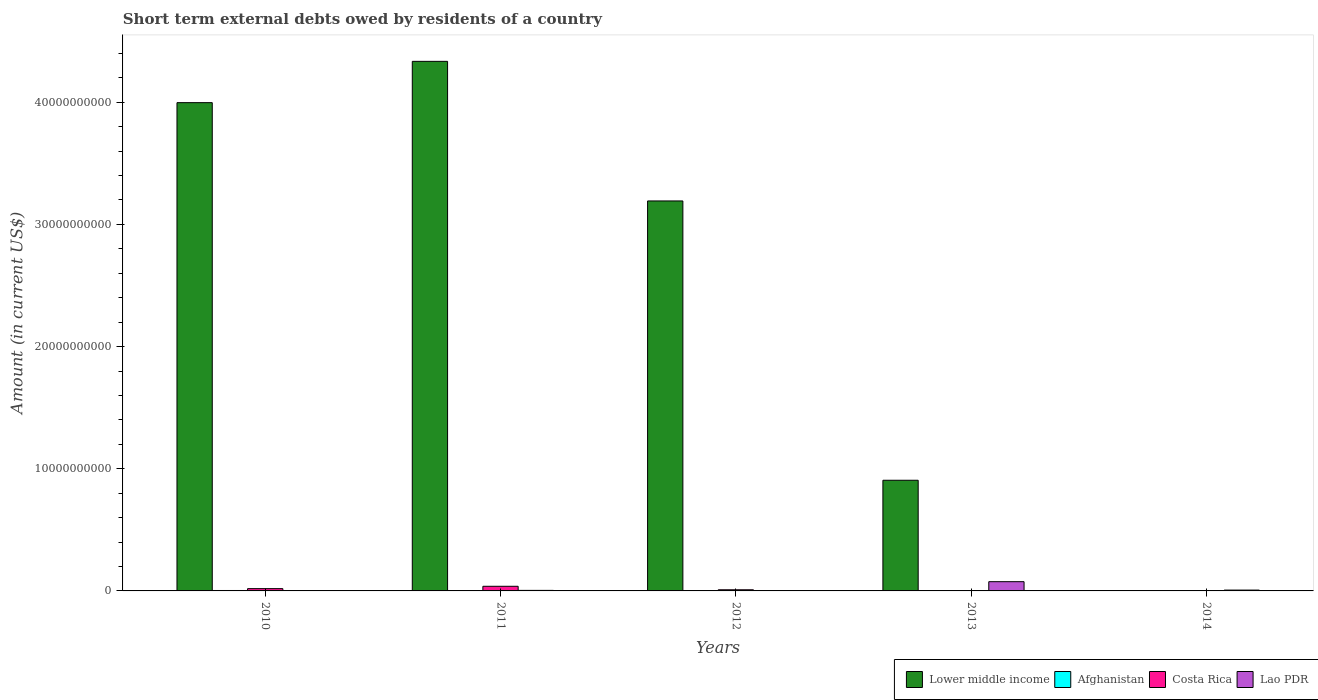How many groups of bars are there?
Provide a short and direct response. 5. What is the label of the 2nd group of bars from the left?
Ensure brevity in your answer.  2011. What is the amount of short-term external debts owed by residents in Lower middle income in 2013?
Ensure brevity in your answer.  9.06e+09. Across all years, what is the maximum amount of short-term external debts owed by residents in Afghanistan?
Your response must be concise. 3.50e+07. Across all years, what is the minimum amount of short-term external debts owed by residents in Lao PDR?
Ensure brevity in your answer.  0. What is the total amount of short-term external debts owed by residents in Costa Rica in the graph?
Your response must be concise. 6.60e+08. What is the difference between the amount of short-term external debts owed by residents in Costa Rica in 2011 and that in 2012?
Keep it short and to the point. 2.86e+08. What is the difference between the amount of short-term external debts owed by residents in Lower middle income in 2011 and the amount of short-term external debts owed by residents in Lao PDR in 2014?
Offer a very short reply. 4.33e+1. What is the average amount of short-term external debts owed by residents in Afghanistan per year?
Ensure brevity in your answer.  1.16e+07. In the year 2011, what is the difference between the amount of short-term external debts owed by residents in Costa Rica and amount of short-term external debts owed by residents in Lower middle income?
Keep it short and to the point. -4.30e+1. In how many years, is the amount of short-term external debts owed by residents in Lao PDR greater than 28000000000 US$?
Give a very brief answer. 0. What is the ratio of the amount of short-term external debts owed by residents in Afghanistan in 2012 to that in 2014?
Provide a short and direct response. 0.64. Is the difference between the amount of short-term external debts owed by residents in Costa Rica in 2011 and 2012 greater than the difference between the amount of short-term external debts owed by residents in Lower middle income in 2011 and 2012?
Your answer should be very brief. No. What is the difference between the highest and the second highest amount of short-term external debts owed by residents in Costa Rica?
Offer a very short reply. 1.92e+08. What is the difference between the highest and the lowest amount of short-term external debts owed by residents in Afghanistan?
Offer a terse response. 3.50e+07. In how many years, is the amount of short-term external debts owed by residents in Lao PDR greater than the average amount of short-term external debts owed by residents in Lao PDR taken over all years?
Offer a terse response. 1. Is the sum of the amount of short-term external debts owed by residents in Lower middle income in 2012 and 2013 greater than the maximum amount of short-term external debts owed by residents in Costa Rica across all years?
Give a very brief answer. Yes. Is it the case that in every year, the sum of the amount of short-term external debts owed by residents in Afghanistan and amount of short-term external debts owed by residents in Lao PDR is greater than the sum of amount of short-term external debts owed by residents in Lower middle income and amount of short-term external debts owed by residents in Costa Rica?
Ensure brevity in your answer.  No. How many bars are there?
Give a very brief answer. 13. Are the values on the major ticks of Y-axis written in scientific E-notation?
Ensure brevity in your answer.  No. Does the graph contain any zero values?
Offer a very short reply. Yes. Does the graph contain grids?
Keep it short and to the point. No. How many legend labels are there?
Make the answer very short. 4. How are the legend labels stacked?
Keep it short and to the point. Horizontal. What is the title of the graph?
Provide a succinct answer. Short term external debts owed by residents of a country. Does "Paraguay" appear as one of the legend labels in the graph?
Provide a short and direct response. No. What is the label or title of the Y-axis?
Keep it short and to the point. Amount (in current US$). What is the Amount (in current US$) in Lower middle income in 2010?
Make the answer very short. 4.00e+1. What is the Amount (in current US$) in Afghanistan in 2010?
Provide a short and direct response. 3.50e+07. What is the Amount (in current US$) of Costa Rica in 2010?
Ensure brevity in your answer.  1.88e+08. What is the Amount (in current US$) of Lao PDR in 2010?
Your response must be concise. 0. What is the Amount (in current US$) in Lower middle income in 2011?
Provide a short and direct response. 4.33e+1. What is the Amount (in current US$) in Costa Rica in 2011?
Keep it short and to the point. 3.79e+08. What is the Amount (in current US$) in Lao PDR in 2011?
Give a very brief answer. 4.40e+07. What is the Amount (in current US$) of Lower middle income in 2012?
Keep it short and to the point. 3.19e+1. What is the Amount (in current US$) of Afghanistan in 2012?
Your response must be concise. 9.00e+06. What is the Amount (in current US$) of Costa Rica in 2012?
Keep it short and to the point. 9.34e+07. What is the Amount (in current US$) in Lower middle income in 2013?
Your answer should be compact. 9.06e+09. What is the Amount (in current US$) of Costa Rica in 2013?
Ensure brevity in your answer.  0. What is the Amount (in current US$) of Lao PDR in 2013?
Your answer should be very brief. 7.56e+08. What is the Amount (in current US$) in Lower middle income in 2014?
Your answer should be very brief. 0. What is the Amount (in current US$) of Afghanistan in 2014?
Offer a very short reply. 1.40e+07. What is the Amount (in current US$) of Lao PDR in 2014?
Keep it short and to the point. 6.80e+07. Across all years, what is the maximum Amount (in current US$) in Lower middle income?
Give a very brief answer. 4.33e+1. Across all years, what is the maximum Amount (in current US$) of Afghanistan?
Keep it short and to the point. 3.50e+07. Across all years, what is the maximum Amount (in current US$) in Costa Rica?
Offer a very short reply. 3.79e+08. Across all years, what is the maximum Amount (in current US$) in Lao PDR?
Keep it short and to the point. 7.56e+08. Across all years, what is the minimum Amount (in current US$) of Lower middle income?
Provide a succinct answer. 0. Across all years, what is the minimum Amount (in current US$) in Afghanistan?
Provide a succinct answer. 0. What is the total Amount (in current US$) in Lower middle income in the graph?
Provide a succinct answer. 1.24e+11. What is the total Amount (in current US$) in Afghanistan in the graph?
Your answer should be very brief. 5.80e+07. What is the total Amount (in current US$) of Costa Rica in the graph?
Make the answer very short. 6.60e+08. What is the total Amount (in current US$) of Lao PDR in the graph?
Offer a very short reply. 8.68e+08. What is the difference between the Amount (in current US$) in Lower middle income in 2010 and that in 2011?
Your answer should be very brief. -3.38e+09. What is the difference between the Amount (in current US$) of Costa Rica in 2010 and that in 2011?
Offer a very short reply. -1.92e+08. What is the difference between the Amount (in current US$) in Lower middle income in 2010 and that in 2012?
Offer a terse response. 8.05e+09. What is the difference between the Amount (in current US$) of Afghanistan in 2010 and that in 2012?
Your answer should be very brief. 2.60e+07. What is the difference between the Amount (in current US$) of Costa Rica in 2010 and that in 2012?
Offer a very short reply. 9.42e+07. What is the difference between the Amount (in current US$) in Lower middle income in 2010 and that in 2013?
Keep it short and to the point. 3.09e+1. What is the difference between the Amount (in current US$) in Afghanistan in 2010 and that in 2014?
Your response must be concise. 2.10e+07. What is the difference between the Amount (in current US$) in Lower middle income in 2011 and that in 2012?
Your answer should be very brief. 1.14e+1. What is the difference between the Amount (in current US$) of Costa Rica in 2011 and that in 2012?
Give a very brief answer. 2.86e+08. What is the difference between the Amount (in current US$) of Lower middle income in 2011 and that in 2013?
Offer a very short reply. 3.43e+1. What is the difference between the Amount (in current US$) in Lao PDR in 2011 and that in 2013?
Offer a terse response. -7.12e+08. What is the difference between the Amount (in current US$) in Lao PDR in 2011 and that in 2014?
Give a very brief answer. -2.40e+07. What is the difference between the Amount (in current US$) in Lower middle income in 2012 and that in 2013?
Your answer should be compact. 2.29e+1. What is the difference between the Amount (in current US$) in Afghanistan in 2012 and that in 2014?
Provide a succinct answer. -5.00e+06. What is the difference between the Amount (in current US$) of Lao PDR in 2013 and that in 2014?
Your response must be concise. 6.88e+08. What is the difference between the Amount (in current US$) in Lower middle income in 2010 and the Amount (in current US$) in Costa Rica in 2011?
Make the answer very short. 3.96e+1. What is the difference between the Amount (in current US$) of Lower middle income in 2010 and the Amount (in current US$) of Lao PDR in 2011?
Keep it short and to the point. 3.99e+1. What is the difference between the Amount (in current US$) of Afghanistan in 2010 and the Amount (in current US$) of Costa Rica in 2011?
Provide a short and direct response. -3.44e+08. What is the difference between the Amount (in current US$) in Afghanistan in 2010 and the Amount (in current US$) in Lao PDR in 2011?
Provide a succinct answer. -9.00e+06. What is the difference between the Amount (in current US$) of Costa Rica in 2010 and the Amount (in current US$) of Lao PDR in 2011?
Ensure brevity in your answer.  1.44e+08. What is the difference between the Amount (in current US$) in Lower middle income in 2010 and the Amount (in current US$) in Afghanistan in 2012?
Ensure brevity in your answer.  4.00e+1. What is the difference between the Amount (in current US$) of Lower middle income in 2010 and the Amount (in current US$) of Costa Rica in 2012?
Offer a very short reply. 3.99e+1. What is the difference between the Amount (in current US$) in Afghanistan in 2010 and the Amount (in current US$) in Costa Rica in 2012?
Provide a succinct answer. -5.84e+07. What is the difference between the Amount (in current US$) in Lower middle income in 2010 and the Amount (in current US$) in Lao PDR in 2013?
Provide a succinct answer. 3.92e+1. What is the difference between the Amount (in current US$) of Afghanistan in 2010 and the Amount (in current US$) of Lao PDR in 2013?
Your answer should be compact. -7.21e+08. What is the difference between the Amount (in current US$) of Costa Rica in 2010 and the Amount (in current US$) of Lao PDR in 2013?
Your response must be concise. -5.68e+08. What is the difference between the Amount (in current US$) in Lower middle income in 2010 and the Amount (in current US$) in Afghanistan in 2014?
Make the answer very short. 4.00e+1. What is the difference between the Amount (in current US$) in Lower middle income in 2010 and the Amount (in current US$) in Lao PDR in 2014?
Offer a very short reply. 3.99e+1. What is the difference between the Amount (in current US$) in Afghanistan in 2010 and the Amount (in current US$) in Lao PDR in 2014?
Offer a very short reply. -3.30e+07. What is the difference between the Amount (in current US$) in Costa Rica in 2010 and the Amount (in current US$) in Lao PDR in 2014?
Your answer should be very brief. 1.20e+08. What is the difference between the Amount (in current US$) of Lower middle income in 2011 and the Amount (in current US$) of Afghanistan in 2012?
Give a very brief answer. 4.33e+1. What is the difference between the Amount (in current US$) of Lower middle income in 2011 and the Amount (in current US$) of Costa Rica in 2012?
Your answer should be very brief. 4.33e+1. What is the difference between the Amount (in current US$) in Lower middle income in 2011 and the Amount (in current US$) in Lao PDR in 2013?
Offer a very short reply. 4.26e+1. What is the difference between the Amount (in current US$) in Costa Rica in 2011 and the Amount (in current US$) in Lao PDR in 2013?
Your answer should be very brief. -3.77e+08. What is the difference between the Amount (in current US$) in Lower middle income in 2011 and the Amount (in current US$) in Afghanistan in 2014?
Keep it short and to the point. 4.33e+1. What is the difference between the Amount (in current US$) of Lower middle income in 2011 and the Amount (in current US$) of Lao PDR in 2014?
Keep it short and to the point. 4.33e+1. What is the difference between the Amount (in current US$) in Costa Rica in 2011 and the Amount (in current US$) in Lao PDR in 2014?
Provide a short and direct response. 3.11e+08. What is the difference between the Amount (in current US$) of Lower middle income in 2012 and the Amount (in current US$) of Lao PDR in 2013?
Provide a succinct answer. 3.12e+1. What is the difference between the Amount (in current US$) in Afghanistan in 2012 and the Amount (in current US$) in Lao PDR in 2013?
Offer a terse response. -7.47e+08. What is the difference between the Amount (in current US$) of Costa Rica in 2012 and the Amount (in current US$) of Lao PDR in 2013?
Your answer should be very brief. -6.63e+08. What is the difference between the Amount (in current US$) in Lower middle income in 2012 and the Amount (in current US$) in Afghanistan in 2014?
Your answer should be compact. 3.19e+1. What is the difference between the Amount (in current US$) in Lower middle income in 2012 and the Amount (in current US$) in Lao PDR in 2014?
Give a very brief answer. 3.19e+1. What is the difference between the Amount (in current US$) in Afghanistan in 2012 and the Amount (in current US$) in Lao PDR in 2014?
Your answer should be compact. -5.90e+07. What is the difference between the Amount (in current US$) in Costa Rica in 2012 and the Amount (in current US$) in Lao PDR in 2014?
Provide a succinct answer. 2.54e+07. What is the difference between the Amount (in current US$) in Lower middle income in 2013 and the Amount (in current US$) in Afghanistan in 2014?
Provide a succinct answer. 9.04e+09. What is the difference between the Amount (in current US$) of Lower middle income in 2013 and the Amount (in current US$) of Lao PDR in 2014?
Provide a short and direct response. 8.99e+09. What is the average Amount (in current US$) of Lower middle income per year?
Offer a very short reply. 2.49e+1. What is the average Amount (in current US$) in Afghanistan per year?
Keep it short and to the point. 1.16e+07. What is the average Amount (in current US$) in Costa Rica per year?
Your answer should be compact. 1.32e+08. What is the average Amount (in current US$) in Lao PDR per year?
Give a very brief answer. 1.74e+08. In the year 2010, what is the difference between the Amount (in current US$) of Lower middle income and Amount (in current US$) of Afghanistan?
Provide a short and direct response. 3.99e+1. In the year 2010, what is the difference between the Amount (in current US$) in Lower middle income and Amount (in current US$) in Costa Rica?
Your answer should be very brief. 3.98e+1. In the year 2010, what is the difference between the Amount (in current US$) in Afghanistan and Amount (in current US$) in Costa Rica?
Provide a succinct answer. -1.53e+08. In the year 2011, what is the difference between the Amount (in current US$) in Lower middle income and Amount (in current US$) in Costa Rica?
Your answer should be compact. 4.30e+1. In the year 2011, what is the difference between the Amount (in current US$) in Lower middle income and Amount (in current US$) in Lao PDR?
Offer a terse response. 4.33e+1. In the year 2011, what is the difference between the Amount (in current US$) in Costa Rica and Amount (in current US$) in Lao PDR?
Your answer should be compact. 3.35e+08. In the year 2012, what is the difference between the Amount (in current US$) in Lower middle income and Amount (in current US$) in Afghanistan?
Offer a very short reply. 3.19e+1. In the year 2012, what is the difference between the Amount (in current US$) of Lower middle income and Amount (in current US$) of Costa Rica?
Your response must be concise. 3.18e+1. In the year 2012, what is the difference between the Amount (in current US$) in Afghanistan and Amount (in current US$) in Costa Rica?
Keep it short and to the point. -8.44e+07. In the year 2013, what is the difference between the Amount (in current US$) of Lower middle income and Amount (in current US$) of Lao PDR?
Provide a succinct answer. 8.30e+09. In the year 2014, what is the difference between the Amount (in current US$) of Afghanistan and Amount (in current US$) of Lao PDR?
Offer a very short reply. -5.40e+07. What is the ratio of the Amount (in current US$) in Lower middle income in 2010 to that in 2011?
Provide a short and direct response. 0.92. What is the ratio of the Amount (in current US$) of Costa Rica in 2010 to that in 2011?
Your answer should be very brief. 0.49. What is the ratio of the Amount (in current US$) of Lower middle income in 2010 to that in 2012?
Keep it short and to the point. 1.25. What is the ratio of the Amount (in current US$) of Afghanistan in 2010 to that in 2012?
Give a very brief answer. 3.89. What is the ratio of the Amount (in current US$) in Costa Rica in 2010 to that in 2012?
Offer a very short reply. 2.01. What is the ratio of the Amount (in current US$) in Lower middle income in 2010 to that in 2013?
Ensure brevity in your answer.  4.41. What is the ratio of the Amount (in current US$) in Afghanistan in 2010 to that in 2014?
Ensure brevity in your answer.  2.5. What is the ratio of the Amount (in current US$) in Lower middle income in 2011 to that in 2012?
Offer a very short reply. 1.36. What is the ratio of the Amount (in current US$) of Costa Rica in 2011 to that in 2012?
Provide a succinct answer. 4.06. What is the ratio of the Amount (in current US$) in Lower middle income in 2011 to that in 2013?
Make the answer very short. 4.79. What is the ratio of the Amount (in current US$) in Lao PDR in 2011 to that in 2013?
Ensure brevity in your answer.  0.06. What is the ratio of the Amount (in current US$) in Lao PDR in 2011 to that in 2014?
Offer a terse response. 0.65. What is the ratio of the Amount (in current US$) of Lower middle income in 2012 to that in 2013?
Give a very brief answer. 3.52. What is the ratio of the Amount (in current US$) of Afghanistan in 2012 to that in 2014?
Provide a succinct answer. 0.64. What is the ratio of the Amount (in current US$) in Lao PDR in 2013 to that in 2014?
Make the answer very short. 11.12. What is the difference between the highest and the second highest Amount (in current US$) in Lower middle income?
Your response must be concise. 3.38e+09. What is the difference between the highest and the second highest Amount (in current US$) in Afghanistan?
Keep it short and to the point. 2.10e+07. What is the difference between the highest and the second highest Amount (in current US$) in Costa Rica?
Your response must be concise. 1.92e+08. What is the difference between the highest and the second highest Amount (in current US$) in Lao PDR?
Provide a succinct answer. 6.88e+08. What is the difference between the highest and the lowest Amount (in current US$) of Lower middle income?
Offer a very short reply. 4.33e+1. What is the difference between the highest and the lowest Amount (in current US$) in Afghanistan?
Keep it short and to the point. 3.50e+07. What is the difference between the highest and the lowest Amount (in current US$) in Costa Rica?
Keep it short and to the point. 3.79e+08. What is the difference between the highest and the lowest Amount (in current US$) in Lao PDR?
Provide a short and direct response. 7.56e+08. 